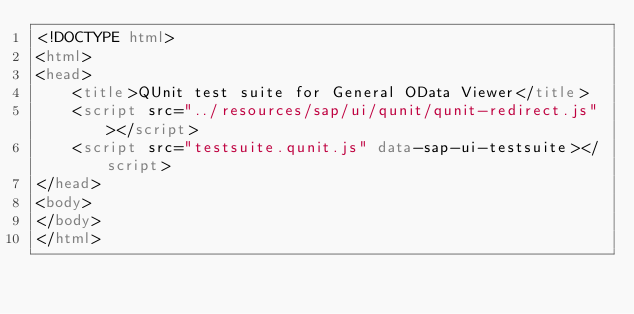<code> <loc_0><loc_0><loc_500><loc_500><_HTML_><!DOCTYPE html>
<html>
<head>
	<title>QUnit test suite for General OData Viewer</title>
	<script src="../resources/sap/ui/qunit/qunit-redirect.js"></script>
	<script src="testsuite.qunit.js" data-sap-ui-testsuite></script>
</head>
<body>
</body>
</html></code> 